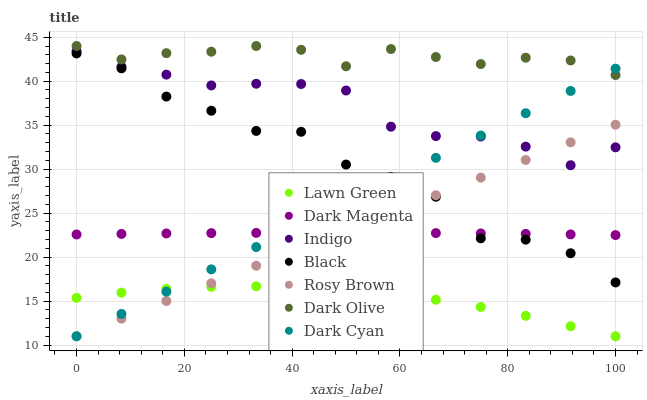Does Lawn Green have the minimum area under the curve?
Answer yes or no. Yes. Does Dark Olive have the maximum area under the curve?
Answer yes or no. Yes. Does Rosy Brown have the minimum area under the curve?
Answer yes or no. No. Does Rosy Brown have the maximum area under the curve?
Answer yes or no. No. Is Rosy Brown the smoothest?
Answer yes or no. Yes. Is Black the roughest?
Answer yes or no. Yes. Is Indigo the smoothest?
Answer yes or no. No. Is Indigo the roughest?
Answer yes or no. No. Does Lawn Green have the lowest value?
Answer yes or no. Yes. Does Indigo have the lowest value?
Answer yes or no. No. Does Dark Olive have the highest value?
Answer yes or no. Yes. Does Rosy Brown have the highest value?
Answer yes or no. No. Is Lawn Green less than Indigo?
Answer yes or no. Yes. Is Indigo greater than Black?
Answer yes or no. Yes. Does Dark Cyan intersect Lawn Green?
Answer yes or no. Yes. Is Dark Cyan less than Lawn Green?
Answer yes or no. No. Is Dark Cyan greater than Lawn Green?
Answer yes or no. No. Does Lawn Green intersect Indigo?
Answer yes or no. No. 